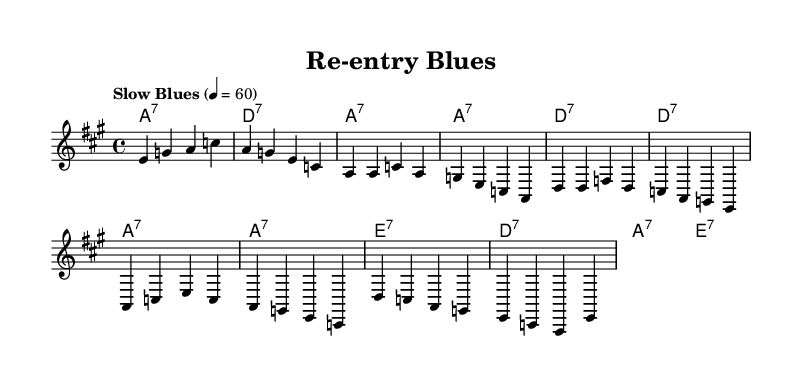What is the key signature of this music? The key signature is indicated by the raised 'a' shown in the upper left corner, which signifies A major, having three sharps.
Answer: A major What is the time signature of this music? The time signature is represented in the upper part of the sheet music, which shows "4/4". This means there are four beats in each measure and the quarter note gets one beat.
Answer: 4/4 What is the tempo marking of this music? The tempo is specified clearly above the staff as "Slow Blues," which describes the speed and style in which the piece should be played.
Answer: Slow Blues How many measures are in the verse? The verse section contains the line with the melody notes and is the first part before the chorus. Counting the measures in the verse, there are four measures present.
Answer: 4 What chord follows the E7 in the chorus? The chorus is structured with a sequence of chords indicated in the chord names below the melody. After E7, the next chord is A7 as seen in the chord progression.
Answer: A7 What type of musical form is used in this blues song? The structure of this blues song includes a repeating format of verses and choruses emphasizing a narrative, common in blues, which is characterized by a twelve-bar structure.
Answer: Verse-Chorus 